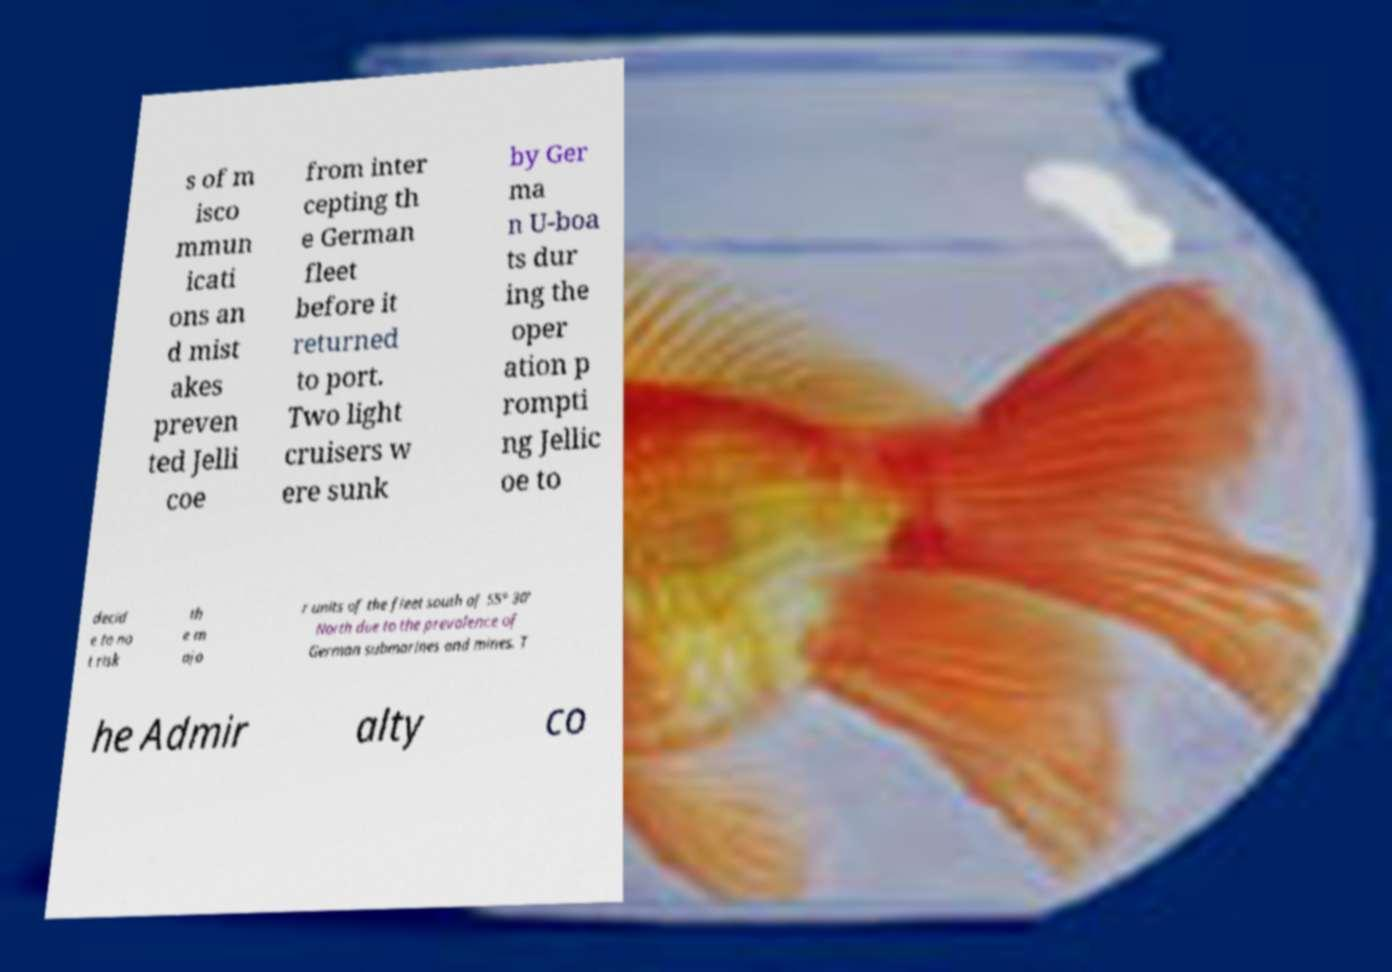I need the written content from this picture converted into text. Can you do that? s of m isco mmun icati ons an d mist akes preven ted Jelli coe from inter cepting th e German fleet before it returned to port. Two light cruisers w ere sunk by Ger ma n U-boa ts dur ing the oper ation p rompti ng Jellic oe to decid e to no t risk th e m ajo r units of the fleet south of 55° 30' North due to the prevalence of German submarines and mines. T he Admir alty co 